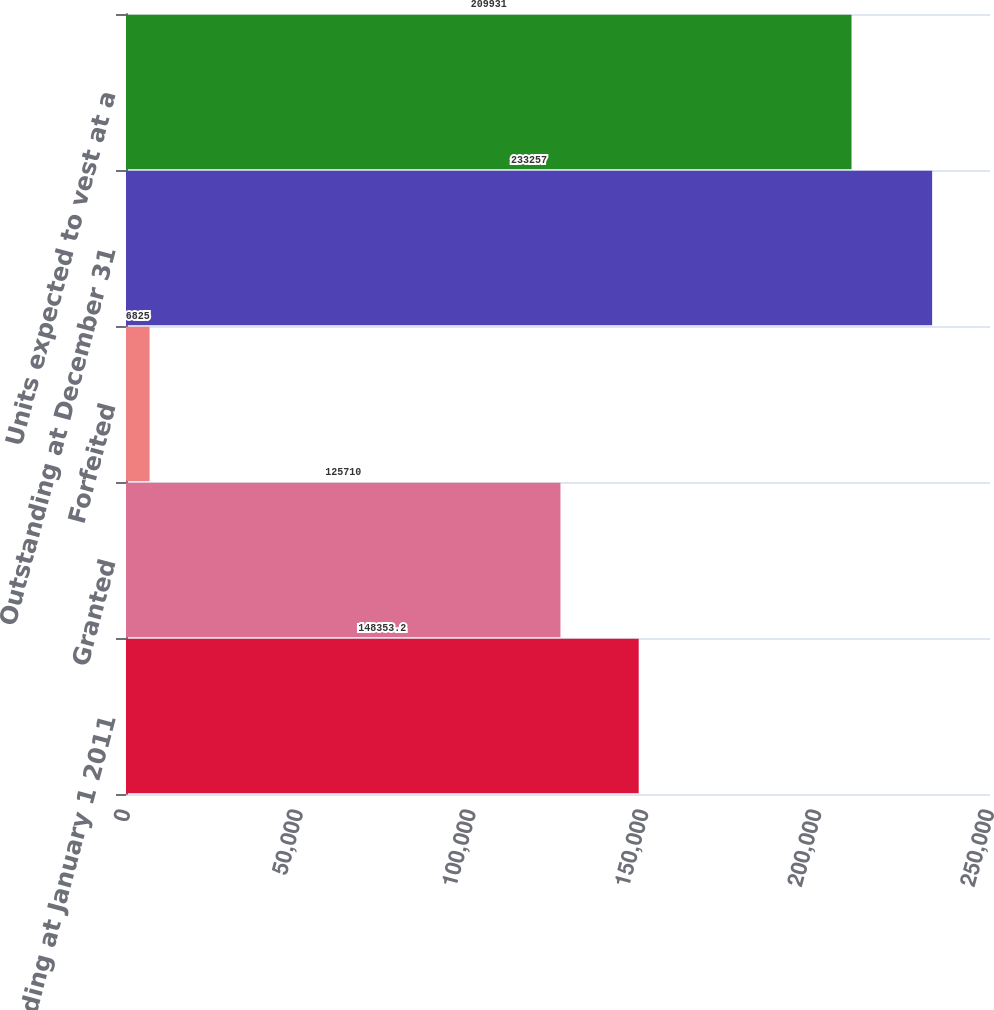Convert chart. <chart><loc_0><loc_0><loc_500><loc_500><bar_chart><fcel>Outstanding at January 1 2011<fcel>Granted<fcel>Forfeited<fcel>Outstanding at December 31<fcel>Units expected to vest at a<nl><fcel>148353<fcel>125710<fcel>6825<fcel>233257<fcel>209931<nl></chart> 